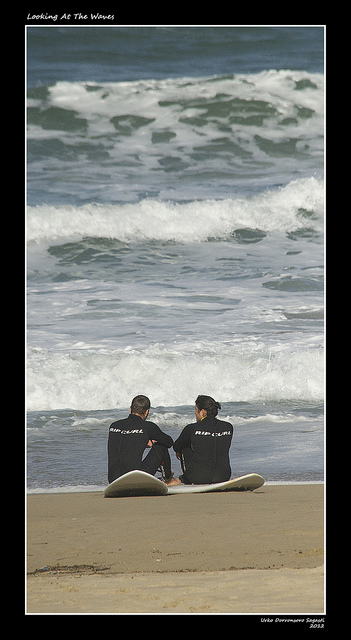How many men are there? 2 